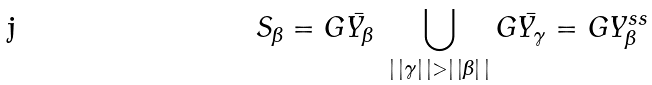<formula> <loc_0><loc_0><loc_500><loc_500>S _ { \beta } = G \bar { Y _ { \beta } } \ \bigcup _ { | \, | \gamma | \, | > | \, | \beta | \, | } G \bar { Y _ { \gamma } } = G Y _ { \beta } ^ { s s }</formula> 